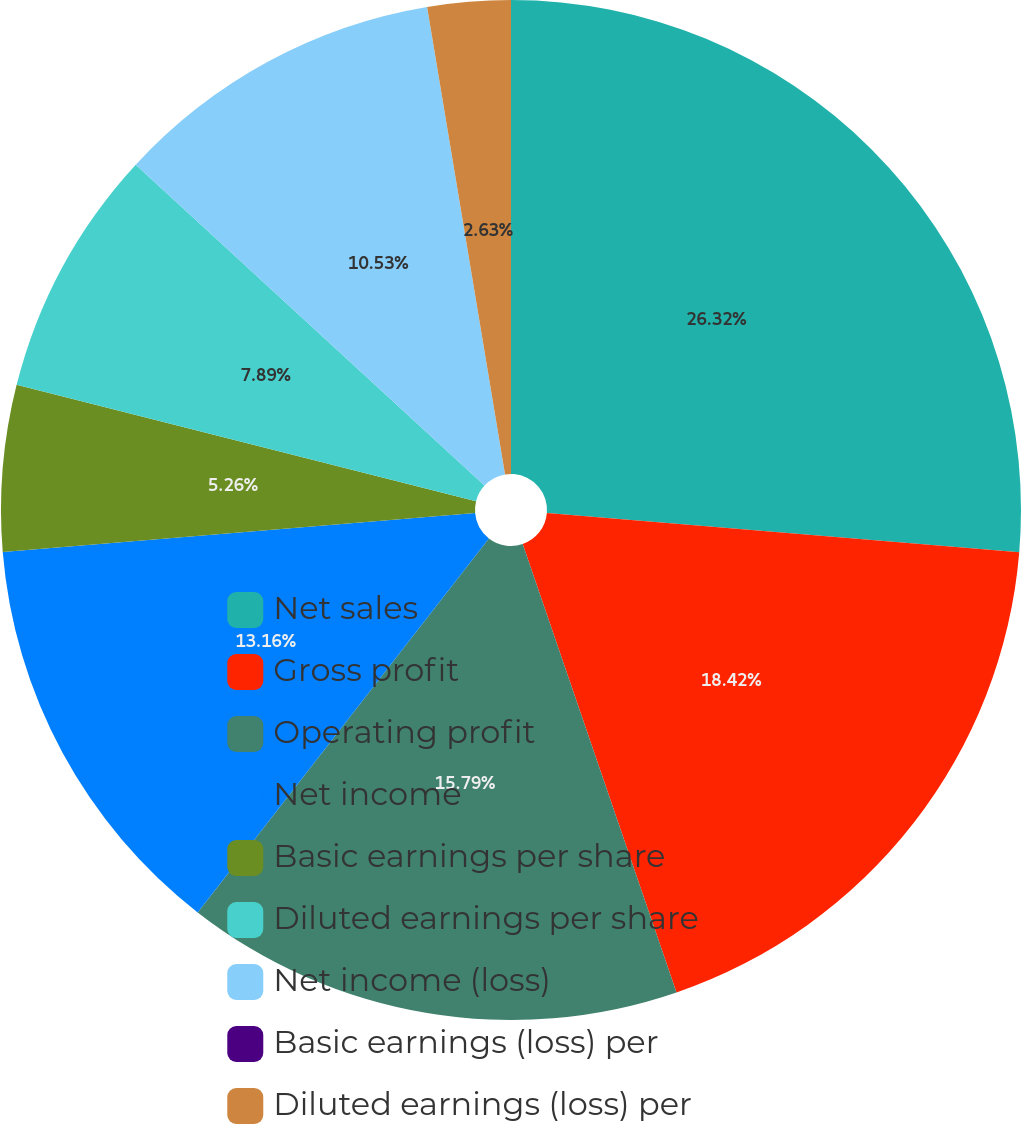<chart> <loc_0><loc_0><loc_500><loc_500><pie_chart><fcel>Net sales<fcel>Gross profit<fcel>Operating profit<fcel>Net income<fcel>Basic earnings per share<fcel>Diluted earnings per share<fcel>Net income (loss)<fcel>Basic earnings (loss) per<fcel>Diluted earnings (loss) per<nl><fcel>26.32%<fcel>18.42%<fcel>15.79%<fcel>13.16%<fcel>5.26%<fcel>7.89%<fcel>10.53%<fcel>0.0%<fcel>2.63%<nl></chart> 